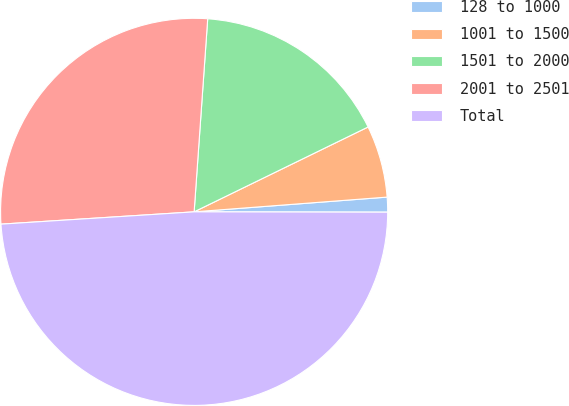Convert chart to OTSL. <chart><loc_0><loc_0><loc_500><loc_500><pie_chart><fcel>128 to 1000<fcel>1001 to 1500<fcel>1501 to 2000<fcel>2001 to 2501<fcel>Total<nl><fcel>1.24%<fcel>6.01%<fcel>16.66%<fcel>27.13%<fcel>48.96%<nl></chart> 